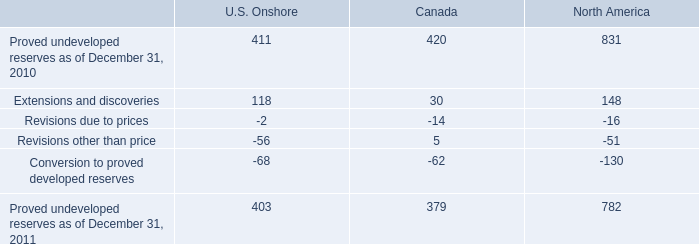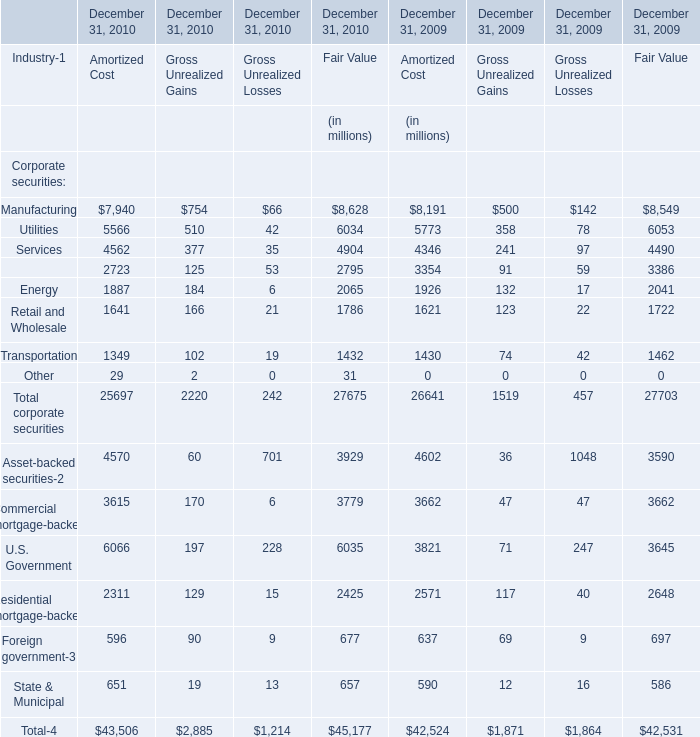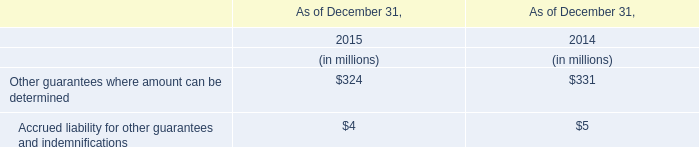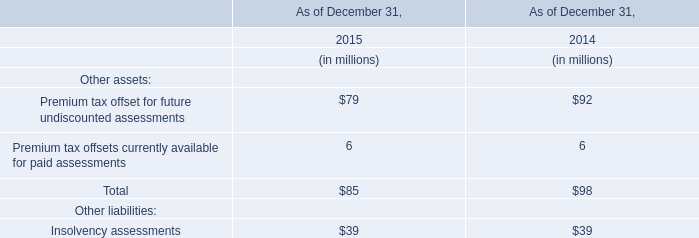What's the sum of the Other guarantees where amount can be determined in the years where Total for Other assets is greater than 0? (in million) 
Computations: (324 + 331)
Answer: 655.0. 